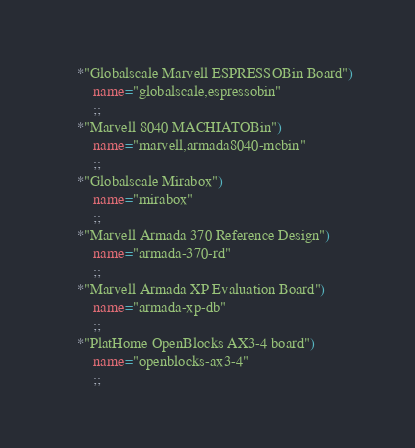<code> <loc_0><loc_0><loc_500><loc_500><_Bash_>	*"Globalscale Marvell ESPRESSOBin Board")
		name="globalscale,espressobin"
		;;
	*"Marvell 8040 MACHIATOBin")
		name="marvell,armada8040-mcbin"
		;;
	*"Globalscale Mirabox")
		name="mirabox"
		;;
	*"Marvell Armada 370 Reference Design")
		name="armada-370-rd"
		;;
	*"Marvell Armada XP Evaluation Board")
		name="armada-xp-db"
		;;
	*"PlatHome OpenBlocks AX3-4 board")
		name="openblocks-ax3-4"
		;;</code> 